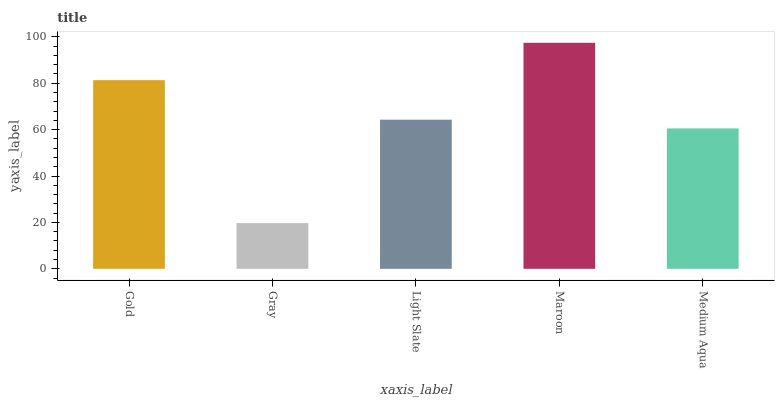Is Gray the minimum?
Answer yes or no. Yes. Is Maroon the maximum?
Answer yes or no. Yes. Is Light Slate the minimum?
Answer yes or no. No. Is Light Slate the maximum?
Answer yes or no. No. Is Light Slate greater than Gray?
Answer yes or no. Yes. Is Gray less than Light Slate?
Answer yes or no. Yes. Is Gray greater than Light Slate?
Answer yes or no. No. Is Light Slate less than Gray?
Answer yes or no. No. Is Light Slate the high median?
Answer yes or no. Yes. Is Light Slate the low median?
Answer yes or no. Yes. Is Gold the high median?
Answer yes or no. No. Is Gold the low median?
Answer yes or no. No. 